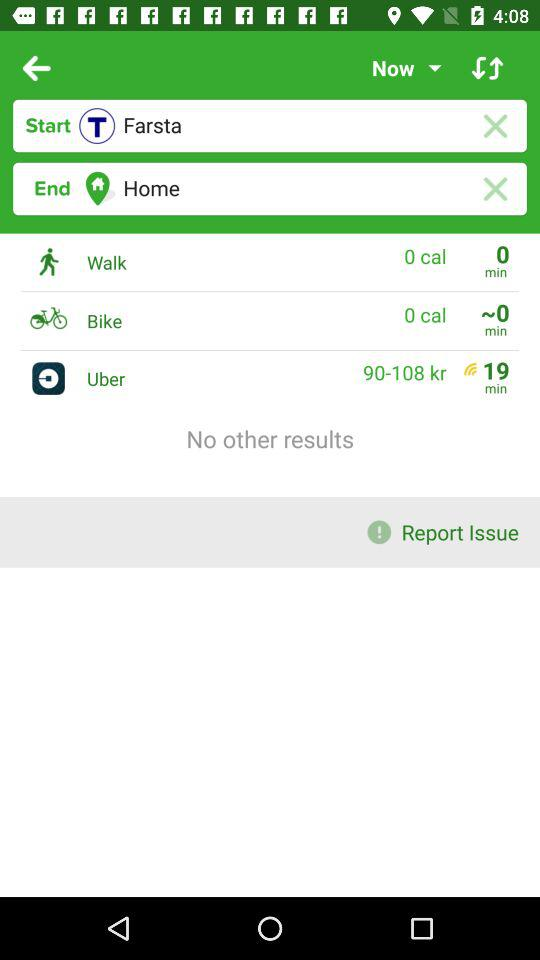What is the starting point? The starting point is Farsta. 